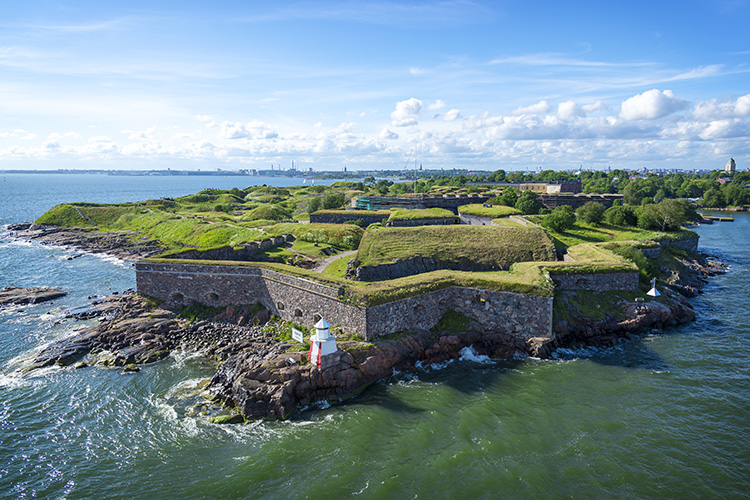Can you tell me more about the historical significance of the Suomenlinna Fortress? Certainly! The Suomenlinna Fortress, originally named Sveaborg, was constructed in the mid-18th century as a maritime fortress and naval base. It played a pivotal role in the defense against sea invasions in the Baltic Sea. Over the centuries, it has served under Swedish, Russian, and Finnish control, reflecting the tumultuous history of the region. Today, it is not only a UNESCO World Heritage site but also a living community with residents and local businesses, making it a rare blend of history, culture, and everyday life. 